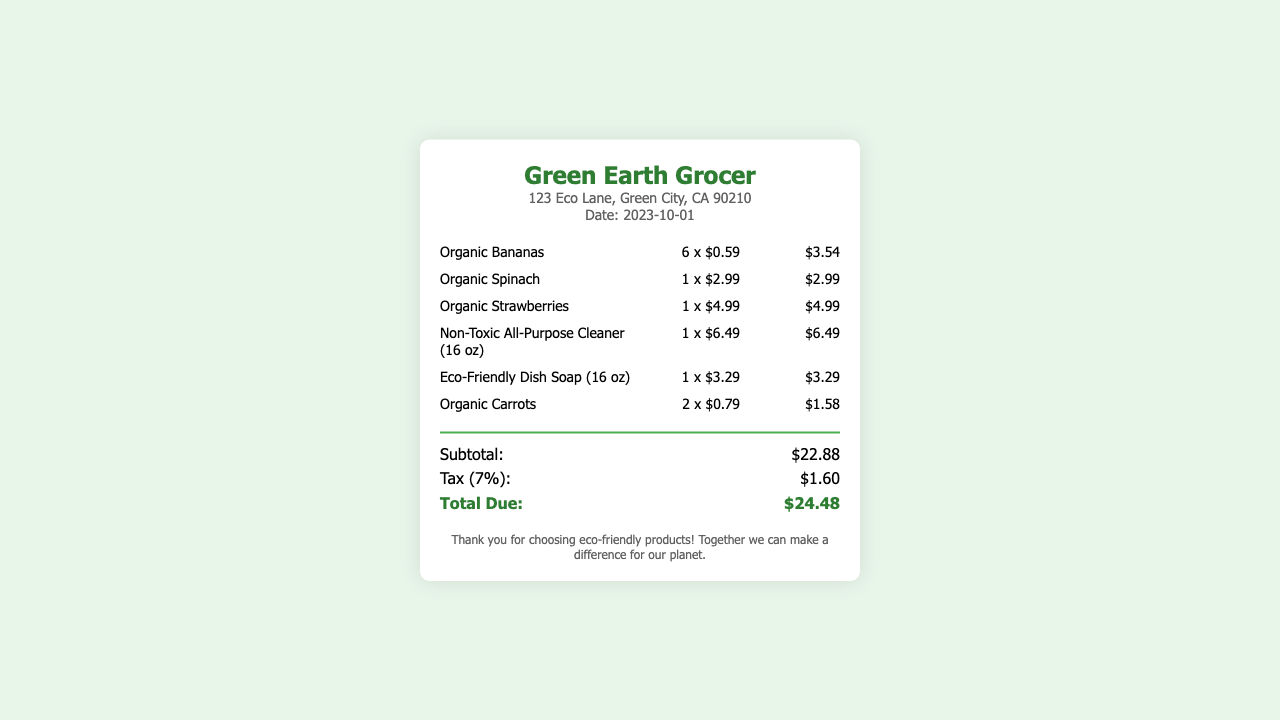What is the date of the purchase? The date is stated in the receipt as "2023-10-01."
Answer: 2023-10-01 What store is this receipt from? The store name is displayed prominently at the top of the receipt as "Green Earth Grocer."
Answer: Green Earth Grocer How many Organic Bananas were purchased? The receipt lists "6 x $0.59" for Organic Bananas, indicating 6 were bought.
Answer: 6 What is the price of the Non-Toxic All-Purpose Cleaner? The item price for the Non-Toxic All-Purpose Cleaner is "$6.49."
Answer: $6.49 What is the subtotal of the purchase? The subtotal is clearly labeled as "$22.88" on the receipt.
Answer: $22.88 What is the total amount due including tax? The total due at the bottom of the receipt is "$24.48."
Answer: $24.48 What percentage was the tax applied to the purchase? The receipt specifies a tax of 7% applied to the subtotal.
Answer: 7% How many types of organic produce were purchased? The receipt lists 3 types of organic produce: Bananas, Spinach, and Carrots.
Answer: 3 What message is displayed at the bottom of the receipt? The footer contains a thank you message that promotes choosing eco-friendly products.
Answer: Thank you for choosing eco-friendly products! 